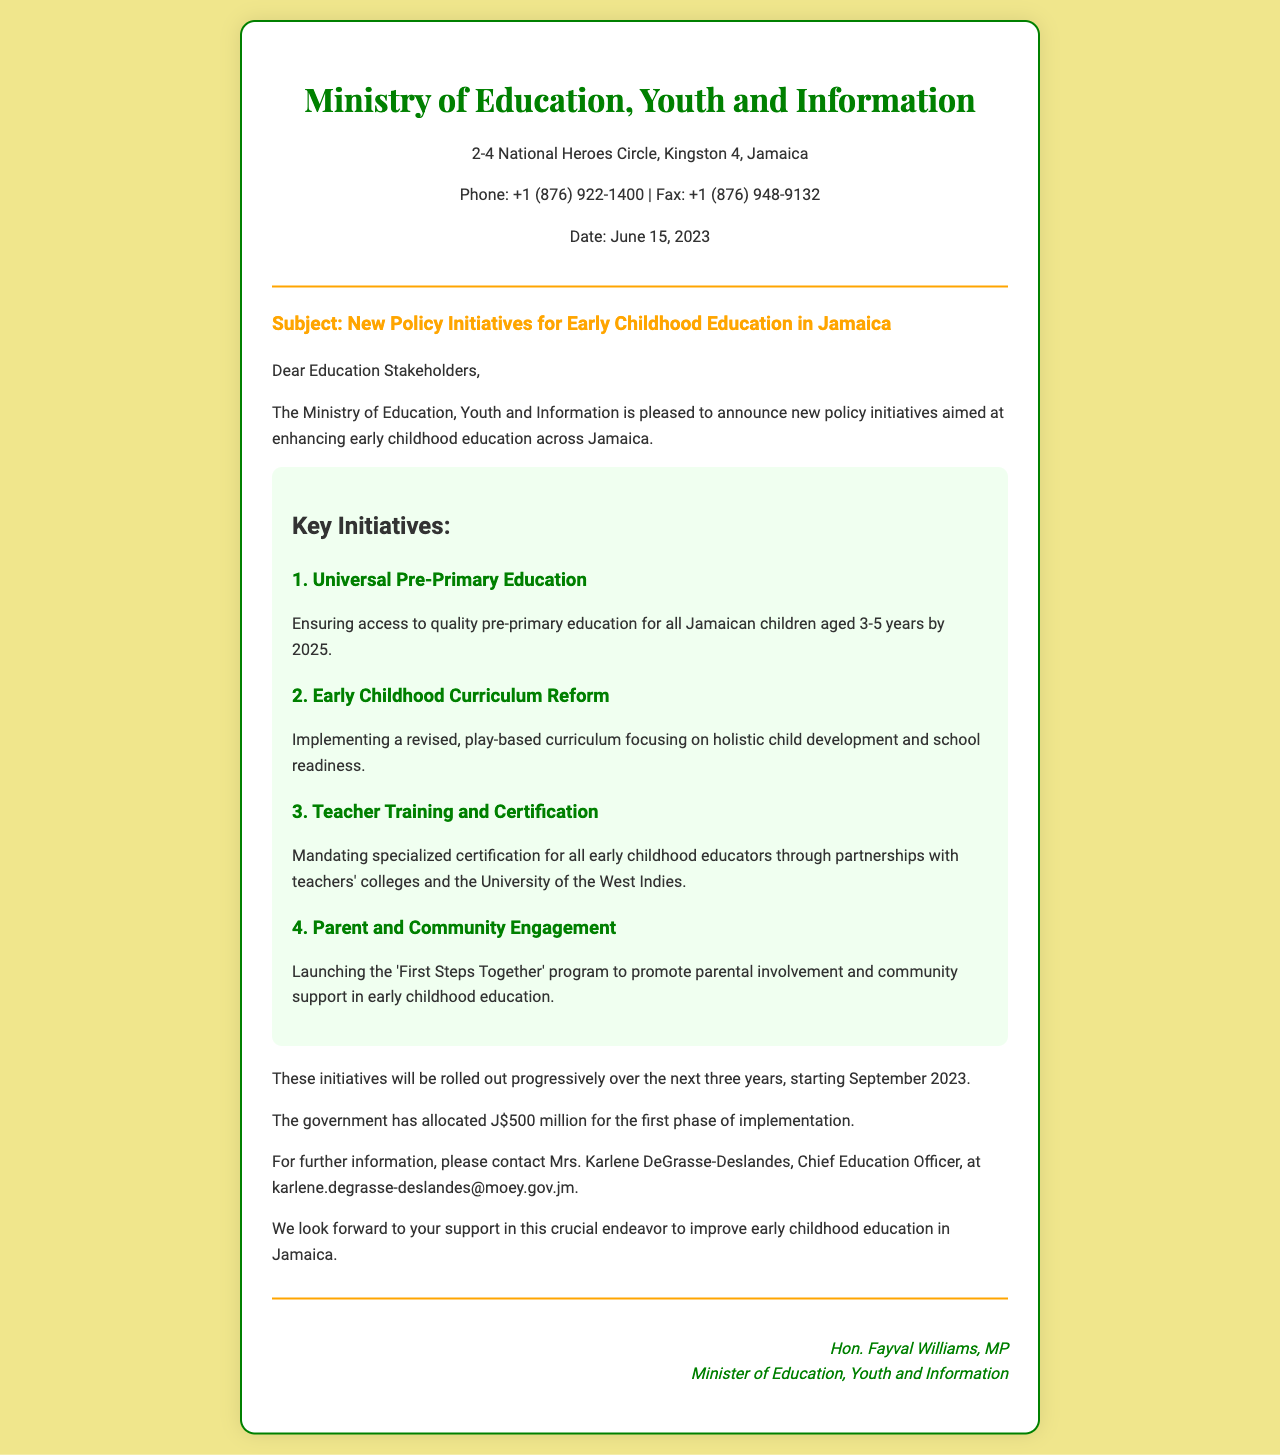What is the date of the fax? The date is indicated in the document and is June 15, 2023.
Answer: June 15, 2023 Who is the Chief Education Officer mentioned in the fax? The document states that the Chief Education Officer is Mrs. Karlene DeGrasse-Deslandes.
Answer: Mrs. Karlene DeGrasse-Deslandes What is the allocated budget for the first phase of implementation? The document specifies that J$500 million has been allocated for the first phase.
Answer: J$500 million What is the main goal of the Universal Pre-Primary Education initiative? This initiative aims to ensure access to quality pre-primary education for children aged 3-5 years.
Answer: Access to quality pre-primary education When will the rollout of initiatives begin? The roll-out of initiatives is scheduled to start in September 2023, as mentioned in the document.
Answer: September 2023 What program is launched to promote parental involvement? The document mentions the 'First Steps Together' program aimed at promoting parental and community engagement.
Answer: 'First Steps Together' program What are the four key initiatives outlined in the document? The initiatives include Universal Pre-Primary Education, Early Childhood Curriculum Reform, Teacher Training and Certification, and Parent and Community Engagement.
Answer: Universal Pre-Primary Education, Early Childhood Curriculum Reform, Teacher Training and Certification, Parent and Community Engagement What is the primary focus of the Early Childhood Curriculum Reform? The reform focuses on a revised, play-based curriculum that emphasizes holistic child development and school readiness.
Answer: Holistic child development and school readiness Who is the Minister of Education mentioned in the fax? The document identifies the Minister of Education as Hon. Fayval Williams, MP.
Answer: Hon. Fayval Williams, MP 